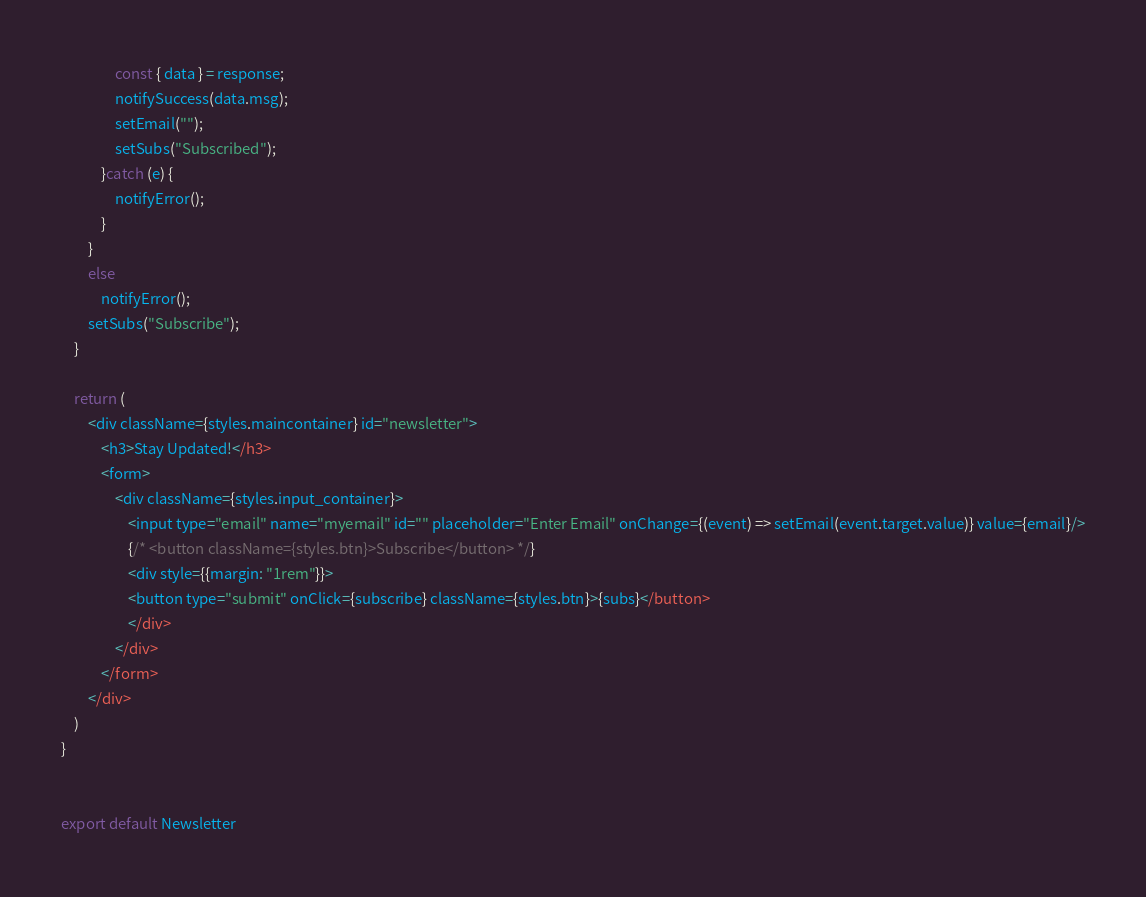<code> <loc_0><loc_0><loc_500><loc_500><_JavaScript_>                const { data } = response;
                notifySuccess(data.msg);
                setEmail("");
                setSubs("Subscribed");
            }catch (e) {
                notifyError();
            }
        }
        else
            notifyError();
        setSubs("Subscribe");
    }

    return (
        <div className={styles.maincontainer} id="newsletter">
            <h3>Stay Updated!</h3>
            <form>
                <div className={styles.input_container}>
                    <input type="email" name="myemail" id="" placeholder="Enter Email" onChange={(event) => setEmail(event.target.value)} value={email}/>
                    {/* <button className={styles.btn}>Subscribe</button> */}
                    <div style={{margin: "1rem"}}>
                    <button type="submit" onClick={subscribe} className={styles.btn}>{subs}</button>
                    </div>
                </div>
            </form>
        </div>
    )
}


export default Newsletter
</code> 